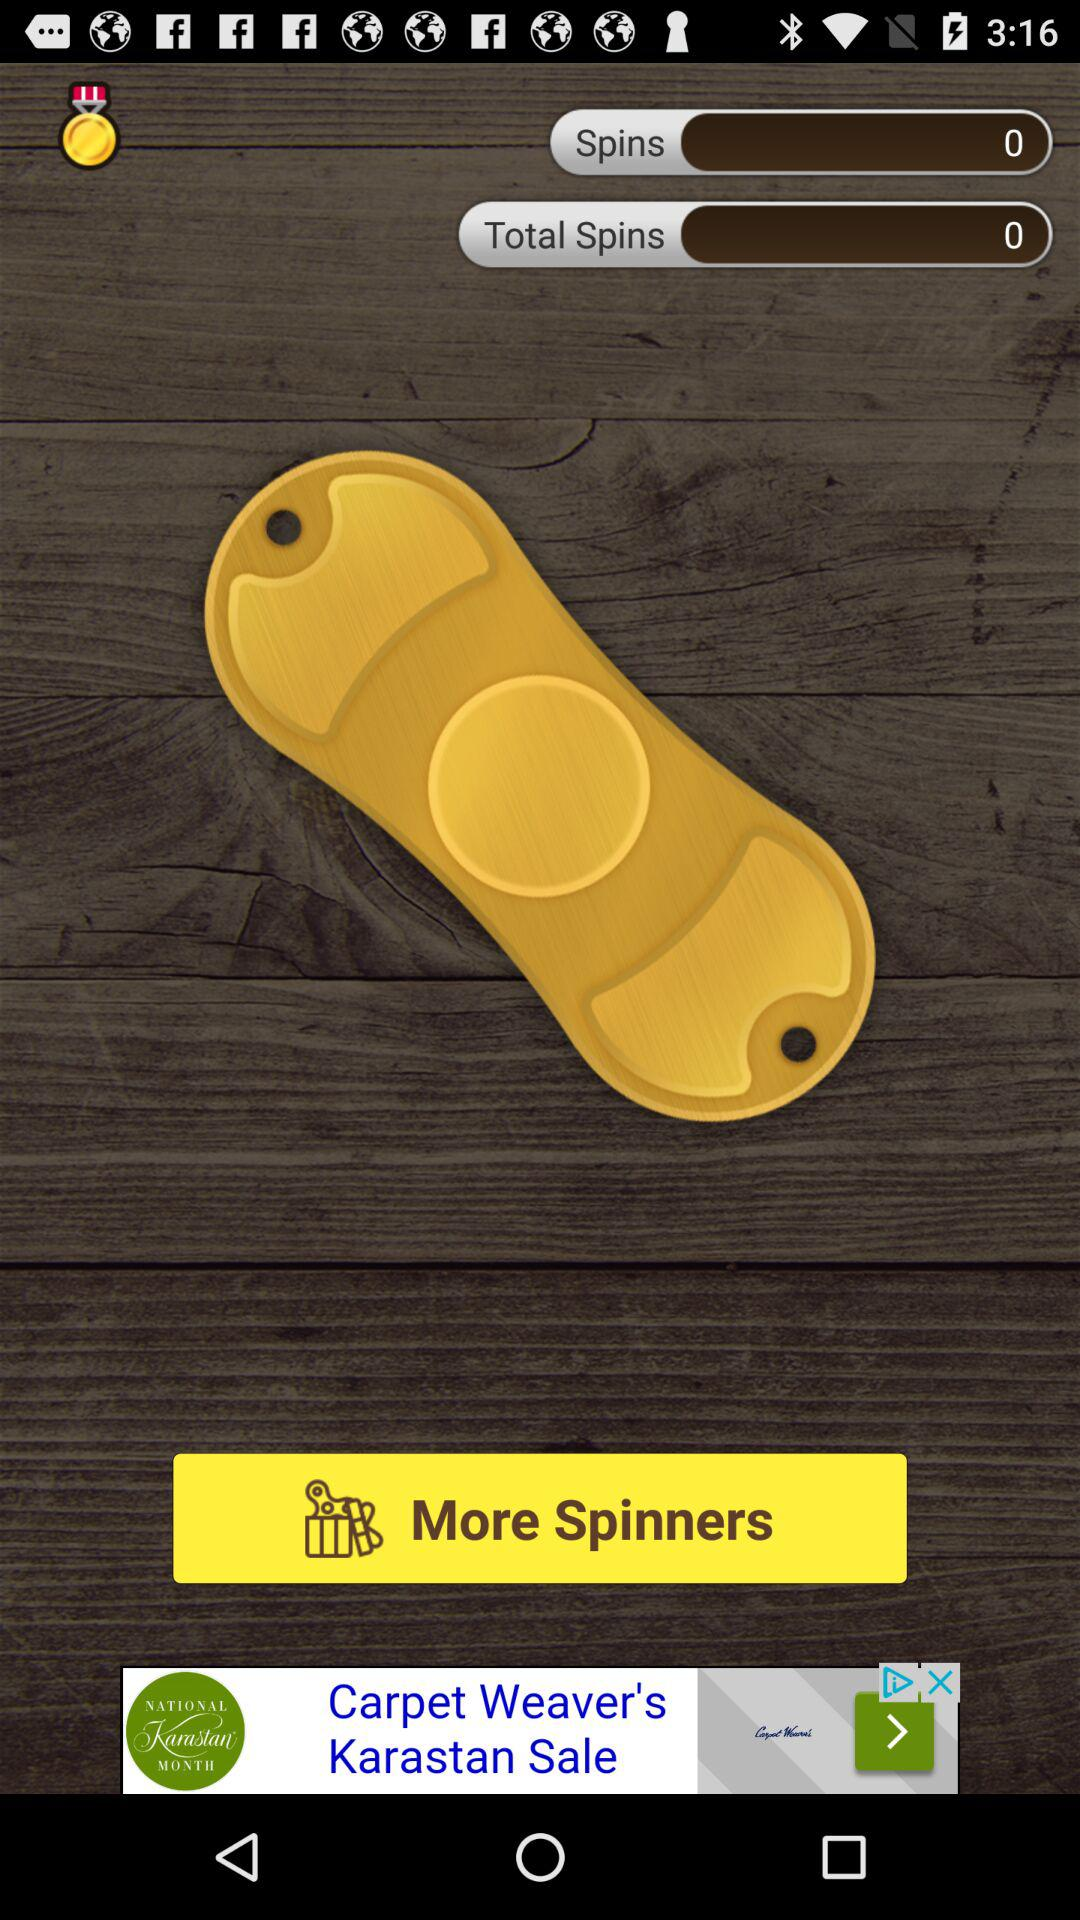What is the number of "Total Spins"? The number of "Total Spins" is 0. 